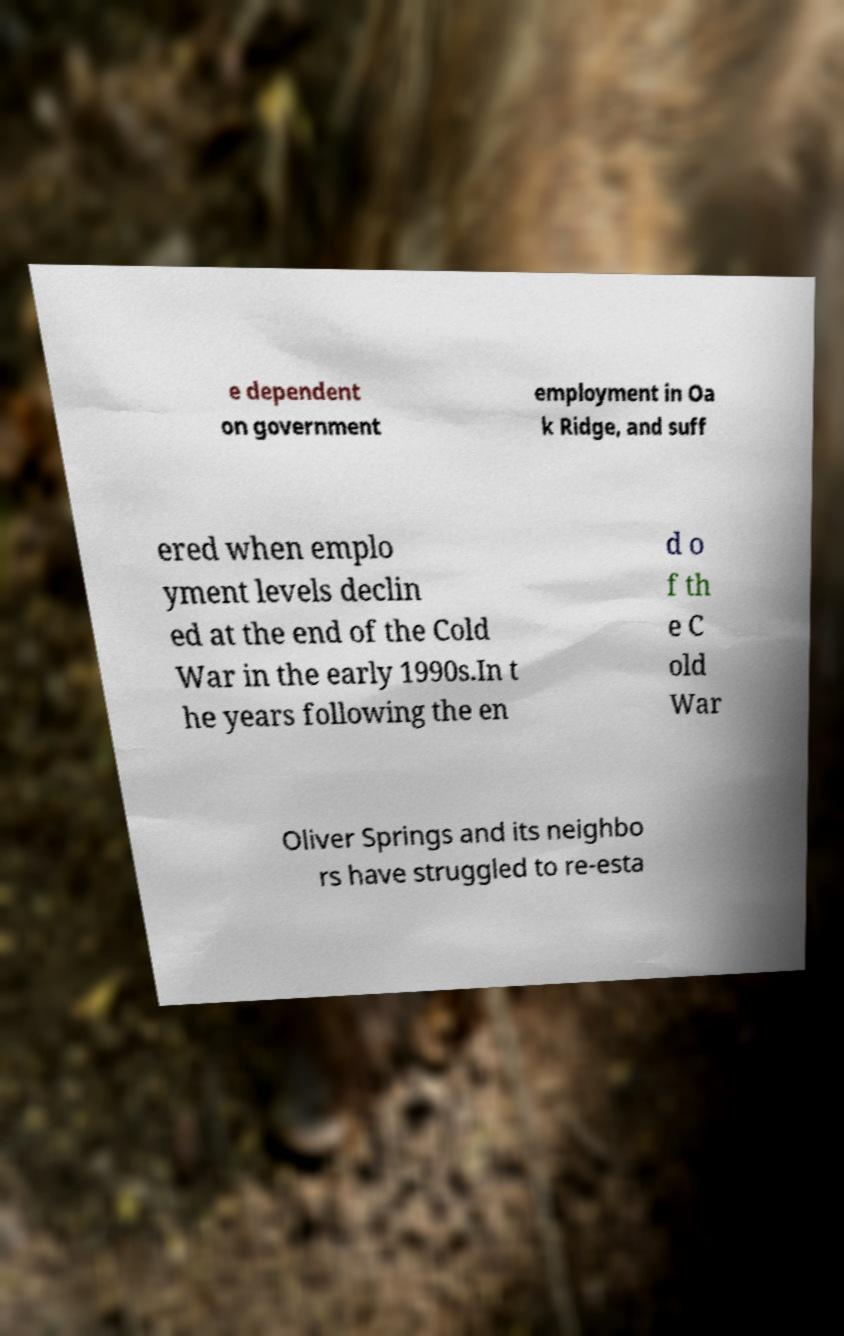Can you accurately transcribe the text from the provided image for me? e dependent on government employment in Oa k Ridge, and suff ered when emplo yment levels declin ed at the end of the Cold War in the early 1990s.In t he years following the en d o f th e C old War Oliver Springs and its neighbo rs have struggled to re-esta 